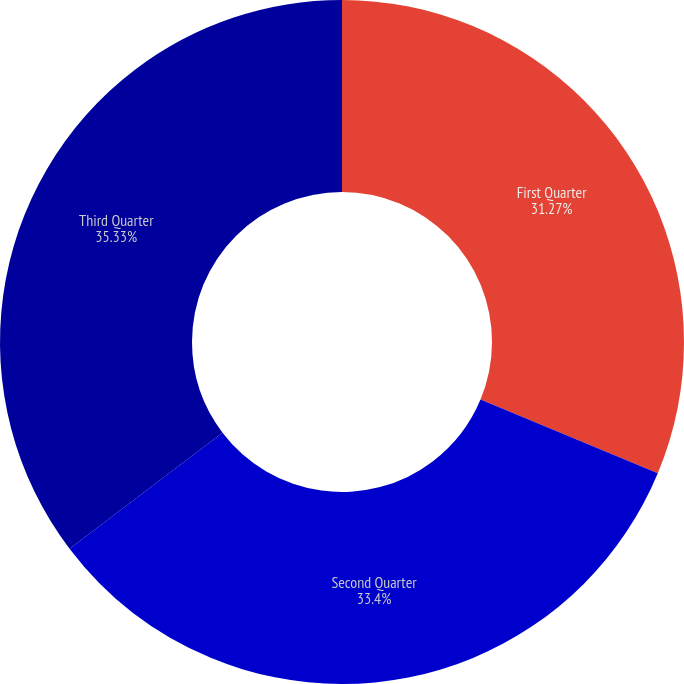Convert chart to OTSL. <chart><loc_0><loc_0><loc_500><loc_500><pie_chart><fcel>First Quarter<fcel>Second Quarter<fcel>Third Quarter<nl><fcel>31.27%<fcel>33.4%<fcel>35.33%<nl></chart> 